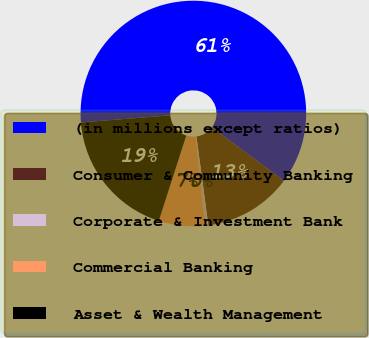<chart> <loc_0><loc_0><loc_500><loc_500><pie_chart><fcel>(in millions except ratios)<fcel>Consumer & Community Banking<fcel>Corporate & Investment Bank<fcel>Commercial Banking<fcel>Asset & Wealth Management<nl><fcel>61.46%<fcel>12.68%<fcel>0.49%<fcel>6.59%<fcel>18.78%<nl></chart> 